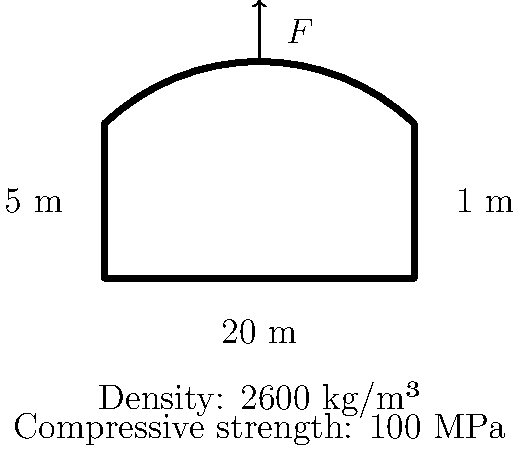A historic stone bridge in the Basque Country, crucial for local transport and cultural heritage, needs assessment. The bridge has a span of 20 m, a width of 5 m, and an arch thickness of 1 m. Given that the stone has a density of 2600 kg/m³ and a compressive strength of 100 MPa, calculate the maximum allowable concentrated load $F$ at the center of the bridge. Assume a safety factor of 2 and that the arch can be approximated as a parabola. To calculate the maximum allowable concentrated load, we'll follow these steps:

1. Calculate the volume of the stone arch:
   $V = L \times W \times T \times \frac{2}{3}$ (parabolic approximation)
   $V = 20 \text{ m} \times 5 \text{ m} \times 1 \text{ m} \times \frac{2}{3} = 66.67 \text{ m}^3$

2. Calculate the weight of the arch:
   $W = V \times \rho \times g$
   $W = 66.67 \text{ m}^3 \times 2600 \text{ kg/m}^3 \times 9.81 \text{ m/s}^2 = 1,702,807 \text{ N}$

3. Calculate the area of the arch at the supports:
   $A = W \times T = 5 \text{ m} \times 1 \text{ m} = 5 \text{ m}^2$

4. Calculate the stress due to the arch's weight:
   $\sigma_{arch} = \frac{W}{2A} = \frac{1,702,807 \text{ N}}{2 \times 5 \text{ m}^2} = 170,281 \text{ Pa}$

5. Calculate the allowable stress with the safety factor:
   $\sigma_{allowable} = \frac{\sigma_{compressive}}{SF} = \frac{100 \times 10^6 \text{ Pa}}{2} = 50 \times 10^6 \text{ Pa}$

6. Calculate the remaining stress capacity:
   $\sigma_{remaining} = \sigma_{allowable} - \sigma_{arch} = 49.83 \times 10^6 \text{ Pa}$

7. Calculate the maximum allowable concentrated load:
   $F = \sigma_{remaining} \times 2A = 49.83 \times 10^6 \text{ Pa} \times 2 \times 5 \text{ m}^2 = 498.3 \times 10^6 \text{ N}$

Therefore, the maximum allowable concentrated load at the center of the bridge is approximately 498.3 MN.
Answer: 498.3 MN 